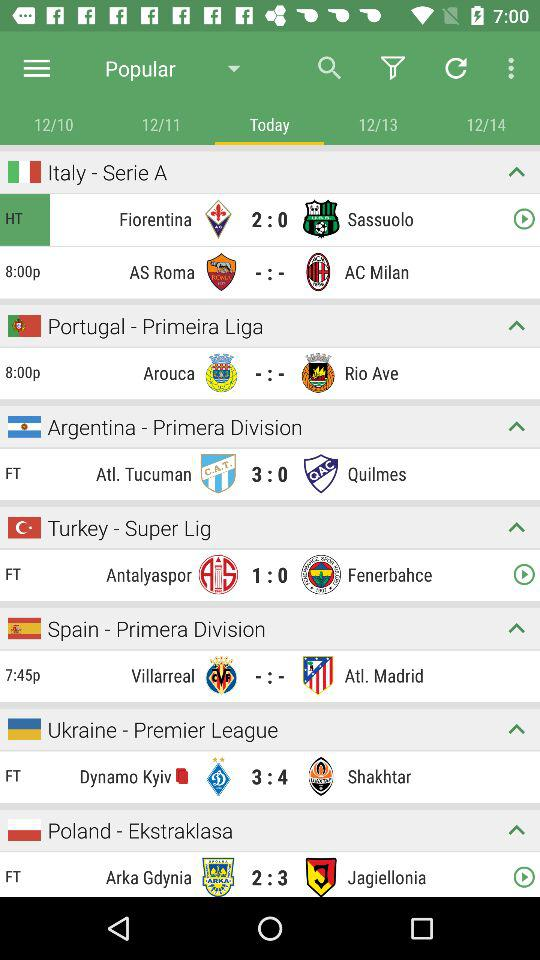Which tab is chosen? The chosen tab is "Today". 